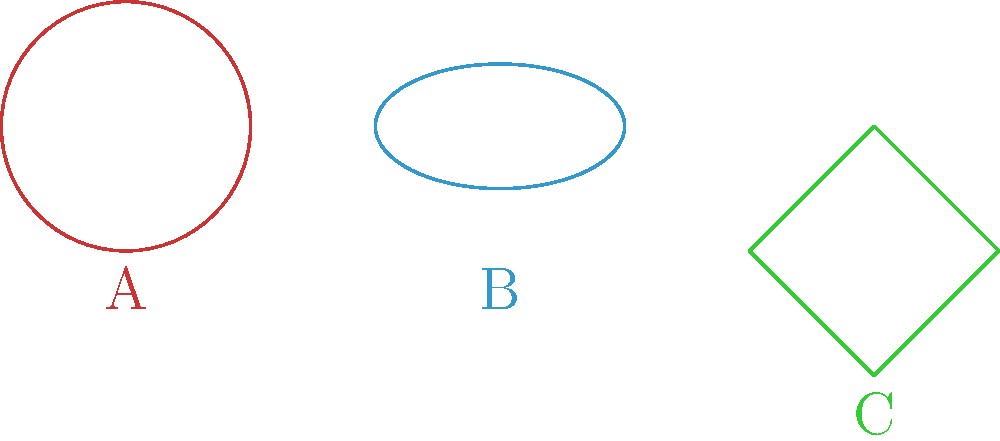In the context of social equity in urban planning, consider the topological properties of three different neighborhood layouts represented by shapes A, B, and C. Which of these shapes has a genus (number of holes) that could represent a layout promoting the most interconnected and accessible community spaces? To answer this question, we need to understand the topological concept of genus and how it relates to community interconnectedness:

1. Shape A (Sphere):
   - Topologically, a sphere has no holes.
   - Genus = 0
   - In urban planning, this could represent a centralized layout with limited interconnections.

2. Shape B (Torus):
   - A torus has one hole.
   - Genus = 1
   - This could represent a layout with a central community space or a circular main street.

3. Shape C (Klein bottle):
   - While not physically realizable in 3D space, topologically, a Klein bottle has no boundary and no holes.
   - Genus = 0 (in 3D projection)
   - This abstract concept could represent a highly interconnected community with no clear boundaries.

In the context of promoting interconnected and accessible community spaces:

- The torus (Shape B) offers the most practical and beneficial layout.
- Its genus of 1 suggests a structure that allows for circular movement and a central community area.
- This layout can promote equity by ensuring all areas are connected and accessible from multiple directions.
- It avoids the centralization of the sphere and the abstract nature of the Klein bottle.

Therefore, Shape B (torus) with a genus of 1 represents the layout that could best promote interconnected and accessible community spaces in an equitable urban plan.
Answer: Shape B (Torus) 